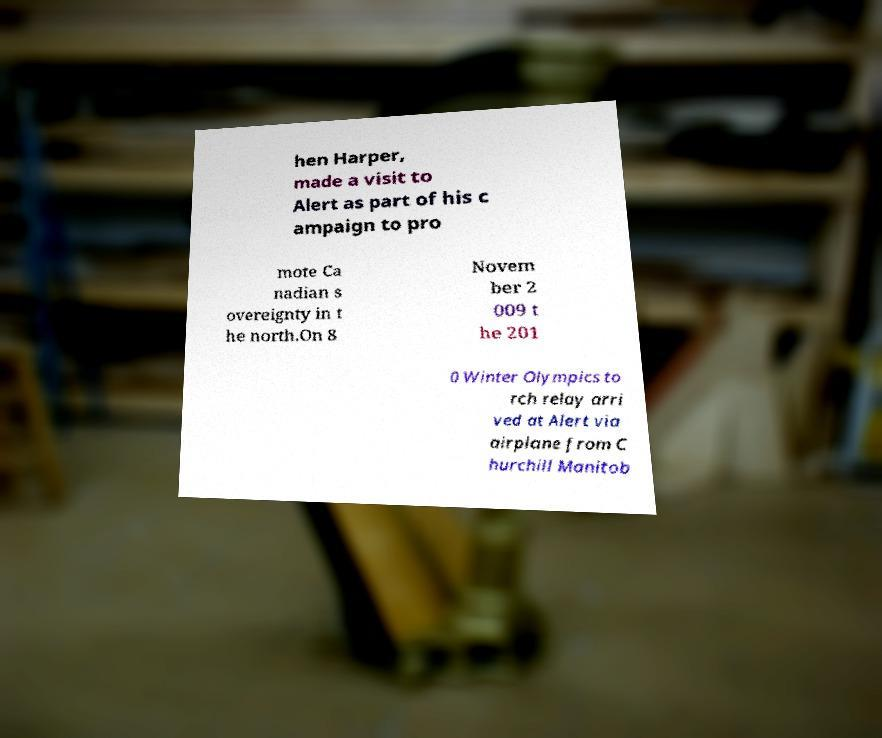I need the written content from this picture converted into text. Can you do that? hen Harper, made a visit to Alert as part of his c ampaign to pro mote Ca nadian s overeignty in t he north.On 8 Novem ber 2 009 t he 201 0 Winter Olympics to rch relay arri ved at Alert via airplane from C hurchill Manitob 